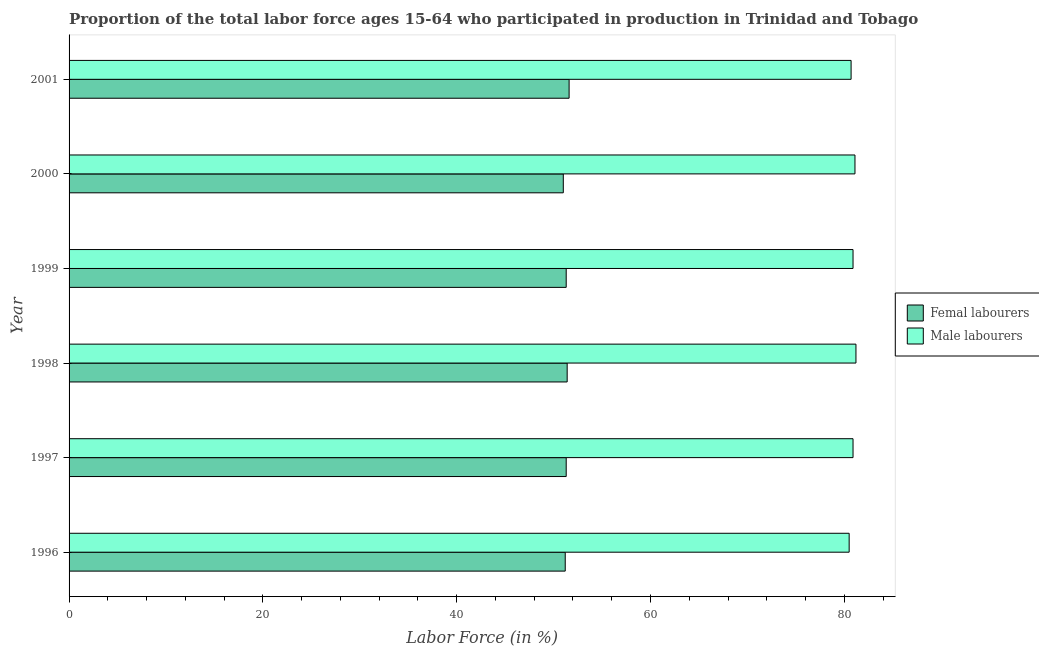Are the number of bars per tick equal to the number of legend labels?
Your answer should be very brief. Yes. Are the number of bars on each tick of the Y-axis equal?
Give a very brief answer. Yes. What is the label of the 4th group of bars from the top?
Your answer should be compact. 1998. What is the percentage of female labor force in 1999?
Make the answer very short. 51.3. Across all years, what is the maximum percentage of male labour force?
Your answer should be compact. 81.2. In which year was the percentage of female labor force maximum?
Give a very brief answer. 2001. In which year was the percentage of female labor force minimum?
Give a very brief answer. 2000. What is the total percentage of female labor force in the graph?
Give a very brief answer. 307.8. What is the difference between the percentage of male labour force in 1998 and the percentage of female labor force in 2001?
Your answer should be compact. 29.6. What is the average percentage of male labour force per year?
Offer a very short reply. 80.88. In the year 2000, what is the difference between the percentage of female labor force and percentage of male labour force?
Keep it short and to the point. -30.1. What is the ratio of the percentage of female labor force in 1996 to that in 2000?
Provide a succinct answer. 1. Is the percentage of female labor force in 1997 less than that in 2001?
Your answer should be very brief. Yes. Is the difference between the percentage of male labour force in 1996 and 2001 greater than the difference between the percentage of female labor force in 1996 and 2001?
Your response must be concise. Yes. What is the difference between the highest and the second highest percentage of male labour force?
Ensure brevity in your answer.  0.1. What is the difference between the highest and the lowest percentage of male labour force?
Provide a short and direct response. 0.7. In how many years, is the percentage of male labour force greater than the average percentage of male labour force taken over all years?
Provide a short and direct response. 4. Is the sum of the percentage of male labour force in 1996 and 1997 greater than the maximum percentage of female labor force across all years?
Give a very brief answer. Yes. What does the 2nd bar from the top in 2000 represents?
Your response must be concise. Femal labourers. What does the 1st bar from the bottom in 1998 represents?
Make the answer very short. Femal labourers. How many bars are there?
Your response must be concise. 12. Are the values on the major ticks of X-axis written in scientific E-notation?
Your response must be concise. No. Where does the legend appear in the graph?
Ensure brevity in your answer.  Center right. How are the legend labels stacked?
Your answer should be very brief. Vertical. What is the title of the graph?
Your response must be concise. Proportion of the total labor force ages 15-64 who participated in production in Trinidad and Tobago. Does "Nonresident" appear as one of the legend labels in the graph?
Offer a terse response. No. What is the label or title of the X-axis?
Offer a terse response. Labor Force (in %). What is the Labor Force (in %) in Femal labourers in 1996?
Offer a terse response. 51.2. What is the Labor Force (in %) of Male labourers in 1996?
Your response must be concise. 80.5. What is the Labor Force (in %) in Femal labourers in 1997?
Provide a short and direct response. 51.3. What is the Labor Force (in %) in Male labourers in 1997?
Provide a short and direct response. 80.9. What is the Labor Force (in %) of Femal labourers in 1998?
Offer a very short reply. 51.4. What is the Labor Force (in %) in Male labourers in 1998?
Ensure brevity in your answer.  81.2. What is the Labor Force (in %) in Femal labourers in 1999?
Give a very brief answer. 51.3. What is the Labor Force (in %) of Male labourers in 1999?
Ensure brevity in your answer.  80.9. What is the Labor Force (in %) of Femal labourers in 2000?
Give a very brief answer. 51. What is the Labor Force (in %) in Male labourers in 2000?
Keep it short and to the point. 81.1. What is the Labor Force (in %) in Femal labourers in 2001?
Make the answer very short. 51.6. What is the Labor Force (in %) of Male labourers in 2001?
Offer a terse response. 80.7. Across all years, what is the maximum Labor Force (in %) of Femal labourers?
Provide a succinct answer. 51.6. Across all years, what is the maximum Labor Force (in %) of Male labourers?
Your answer should be compact. 81.2. Across all years, what is the minimum Labor Force (in %) in Femal labourers?
Offer a terse response. 51. Across all years, what is the minimum Labor Force (in %) in Male labourers?
Your answer should be compact. 80.5. What is the total Labor Force (in %) of Femal labourers in the graph?
Your answer should be compact. 307.8. What is the total Labor Force (in %) of Male labourers in the graph?
Your response must be concise. 485.3. What is the difference between the Labor Force (in %) in Male labourers in 1996 and that in 1997?
Provide a succinct answer. -0.4. What is the difference between the Labor Force (in %) of Femal labourers in 1996 and that in 1998?
Your answer should be compact. -0.2. What is the difference between the Labor Force (in %) of Femal labourers in 1996 and that in 2000?
Offer a very short reply. 0.2. What is the difference between the Labor Force (in %) of Male labourers in 1996 and that in 2000?
Your response must be concise. -0.6. What is the difference between the Labor Force (in %) in Femal labourers in 1997 and that in 1998?
Offer a terse response. -0.1. What is the difference between the Labor Force (in %) of Femal labourers in 1997 and that in 1999?
Keep it short and to the point. 0. What is the difference between the Labor Force (in %) of Male labourers in 1997 and that in 2000?
Ensure brevity in your answer.  -0.2. What is the difference between the Labor Force (in %) of Femal labourers in 1997 and that in 2001?
Keep it short and to the point. -0.3. What is the difference between the Labor Force (in %) in Male labourers in 1997 and that in 2001?
Make the answer very short. 0.2. What is the difference between the Labor Force (in %) of Male labourers in 1998 and that in 2000?
Your response must be concise. 0.1. What is the difference between the Labor Force (in %) in Male labourers in 1999 and that in 2000?
Your answer should be compact. -0.2. What is the difference between the Labor Force (in %) of Femal labourers in 1999 and that in 2001?
Provide a short and direct response. -0.3. What is the difference between the Labor Force (in %) in Male labourers in 1999 and that in 2001?
Offer a terse response. 0.2. What is the difference between the Labor Force (in %) of Femal labourers in 2000 and that in 2001?
Your response must be concise. -0.6. What is the difference between the Labor Force (in %) in Male labourers in 2000 and that in 2001?
Your answer should be very brief. 0.4. What is the difference between the Labor Force (in %) of Femal labourers in 1996 and the Labor Force (in %) of Male labourers in 1997?
Offer a very short reply. -29.7. What is the difference between the Labor Force (in %) of Femal labourers in 1996 and the Labor Force (in %) of Male labourers in 1999?
Offer a very short reply. -29.7. What is the difference between the Labor Force (in %) in Femal labourers in 1996 and the Labor Force (in %) in Male labourers in 2000?
Offer a very short reply. -29.9. What is the difference between the Labor Force (in %) in Femal labourers in 1996 and the Labor Force (in %) in Male labourers in 2001?
Make the answer very short. -29.5. What is the difference between the Labor Force (in %) of Femal labourers in 1997 and the Labor Force (in %) of Male labourers in 1998?
Provide a short and direct response. -29.9. What is the difference between the Labor Force (in %) in Femal labourers in 1997 and the Labor Force (in %) in Male labourers in 1999?
Make the answer very short. -29.6. What is the difference between the Labor Force (in %) of Femal labourers in 1997 and the Labor Force (in %) of Male labourers in 2000?
Provide a succinct answer. -29.8. What is the difference between the Labor Force (in %) in Femal labourers in 1997 and the Labor Force (in %) in Male labourers in 2001?
Make the answer very short. -29.4. What is the difference between the Labor Force (in %) of Femal labourers in 1998 and the Labor Force (in %) of Male labourers in 1999?
Your answer should be very brief. -29.5. What is the difference between the Labor Force (in %) of Femal labourers in 1998 and the Labor Force (in %) of Male labourers in 2000?
Make the answer very short. -29.7. What is the difference between the Labor Force (in %) in Femal labourers in 1998 and the Labor Force (in %) in Male labourers in 2001?
Keep it short and to the point. -29.3. What is the difference between the Labor Force (in %) in Femal labourers in 1999 and the Labor Force (in %) in Male labourers in 2000?
Keep it short and to the point. -29.8. What is the difference between the Labor Force (in %) in Femal labourers in 1999 and the Labor Force (in %) in Male labourers in 2001?
Provide a succinct answer. -29.4. What is the difference between the Labor Force (in %) of Femal labourers in 2000 and the Labor Force (in %) of Male labourers in 2001?
Ensure brevity in your answer.  -29.7. What is the average Labor Force (in %) in Femal labourers per year?
Provide a short and direct response. 51.3. What is the average Labor Force (in %) in Male labourers per year?
Provide a succinct answer. 80.88. In the year 1996, what is the difference between the Labor Force (in %) of Femal labourers and Labor Force (in %) of Male labourers?
Offer a very short reply. -29.3. In the year 1997, what is the difference between the Labor Force (in %) in Femal labourers and Labor Force (in %) in Male labourers?
Your answer should be compact. -29.6. In the year 1998, what is the difference between the Labor Force (in %) in Femal labourers and Labor Force (in %) in Male labourers?
Your answer should be very brief. -29.8. In the year 1999, what is the difference between the Labor Force (in %) in Femal labourers and Labor Force (in %) in Male labourers?
Give a very brief answer. -29.6. In the year 2000, what is the difference between the Labor Force (in %) of Femal labourers and Labor Force (in %) of Male labourers?
Your response must be concise. -30.1. In the year 2001, what is the difference between the Labor Force (in %) in Femal labourers and Labor Force (in %) in Male labourers?
Offer a very short reply. -29.1. What is the ratio of the Labor Force (in %) of Femal labourers in 1996 to that in 1998?
Your answer should be compact. 1. What is the ratio of the Labor Force (in %) of Male labourers in 1996 to that in 1998?
Your answer should be very brief. 0.99. What is the ratio of the Labor Force (in %) of Femal labourers in 1996 to that in 1999?
Offer a terse response. 1. What is the ratio of the Labor Force (in %) in Femal labourers in 1996 to that in 2000?
Keep it short and to the point. 1. What is the ratio of the Labor Force (in %) in Male labourers in 1996 to that in 2000?
Make the answer very short. 0.99. What is the ratio of the Labor Force (in %) in Femal labourers in 1996 to that in 2001?
Provide a short and direct response. 0.99. What is the ratio of the Labor Force (in %) in Male labourers in 1996 to that in 2001?
Keep it short and to the point. 1. What is the ratio of the Labor Force (in %) of Femal labourers in 1997 to that in 1998?
Your response must be concise. 1. What is the ratio of the Labor Force (in %) in Femal labourers in 1997 to that in 2000?
Your response must be concise. 1.01. What is the ratio of the Labor Force (in %) in Femal labourers in 1998 to that in 1999?
Your answer should be compact. 1. What is the ratio of the Labor Force (in %) of Male labourers in 1998 to that in 1999?
Your answer should be very brief. 1. What is the ratio of the Labor Force (in %) of Femal labourers in 1998 to that in 2001?
Offer a very short reply. 1. What is the ratio of the Labor Force (in %) of Male labourers in 1998 to that in 2001?
Provide a short and direct response. 1.01. What is the ratio of the Labor Force (in %) in Femal labourers in 1999 to that in 2000?
Offer a very short reply. 1.01. What is the ratio of the Labor Force (in %) in Femal labourers in 1999 to that in 2001?
Offer a terse response. 0.99. What is the ratio of the Labor Force (in %) of Femal labourers in 2000 to that in 2001?
Your response must be concise. 0.99. What is the ratio of the Labor Force (in %) of Male labourers in 2000 to that in 2001?
Offer a terse response. 1. What is the difference between the highest and the second highest Labor Force (in %) in Femal labourers?
Offer a terse response. 0.2. 